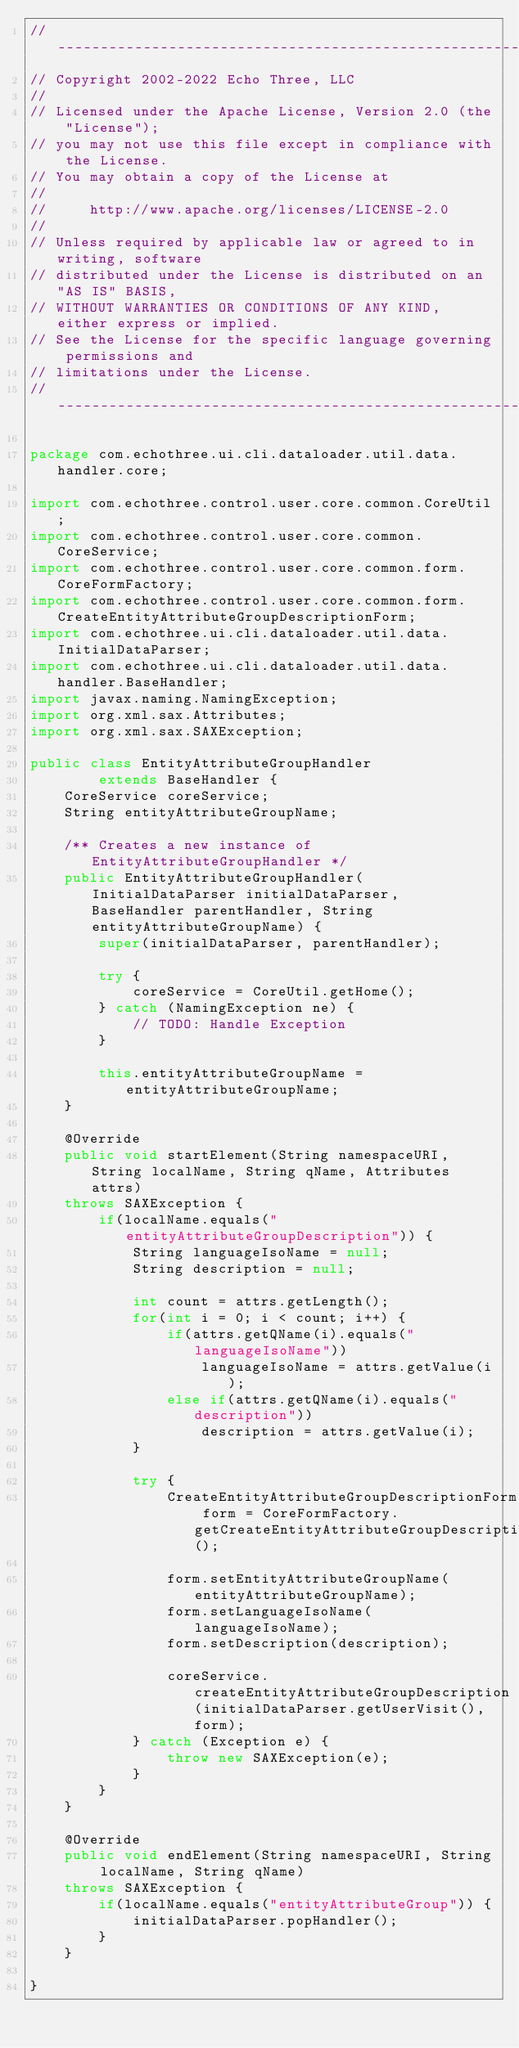Convert code to text. <code><loc_0><loc_0><loc_500><loc_500><_Java_>// --------------------------------------------------------------------------------
// Copyright 2002-2022 Echo Three, LLC
//
// Licensed under the Apache License, Version 2.0 (the "License");
// you may not use this file except in compliance with the License.
// You may obtain a copy of the License at
//
//     http://www.apache.org/licenses/LICENSE-2.0
//
// Unless required by applicable law or agreed to in writing, software
// distributed under the License is distributed on an "AS IS" BASIS,
// WITHOUT WARRANTIES OR CONDITIONS OF ANY KIND, either express or implied.
// See the License for the specific language governing permissions and
// limitations under the License.
// --------------------------------------------------------------------------------

package com.echothree.ui.cli.dataloader.util.data.handler.core;

import com.echothree.control.user.core.common.CoreUtil;
import com.echothree.control.user.core.common.CoreService;
import com.echothree.control.user.core.common.form.CoreFormFactory;
import com.echothree.control.user.core.common.form.CreateEntityAttributeGroupDescriptionForm;
import com.echothree.ui.cli.dataloader.util.data.InitialDataParser;
import com.echothree.ui.cli.dataloader.util.data.handler.BaseHandler;
import javax.naming.NamingException;
import org.xml.sax.Attributes;
import org.xml.sax.SAXException;

public class EntityAttributeGroupHandler
        extends BaseHandler {
    CoreService coreService;
    String entityAttributeGroupName;
    
    /** Creates a new instance of EntityAttributeGroupHandler */
    public EntityAttributeGroupHandler(InitialDataParser initialDataParser, BaseHandler parentHandler, String entityAttributeGroupName) {
        super(initialDataParser, parentHandler);
        
        try {
            coreService = CoreUtil.getHome();
        } catch (NamingException ne) {
            // TODO: Handle Exception
        }
        
        this.entityAttributeGroupName = entityAttributeGroupName;
    }
    
    @Override
    public void startElement(String namespaceURI, String localName, String qName, Attributes attrs)
    throws SAXException {
        if(localName.equals("entityAttributeGroupDescription")) {
            String languageIsoName = null;
            String description = null;
            
            int count = attrs.getLength();
            for(int i = 0; i < count; i++) {
                if(attrs.getQName(i).equals("languageIsoName"))
                    languageIsoName = attrs.getValue(i);
                else if(attrs.getQName(i).equals("description"))
                    description = attrs.getValue(i);
            }
            
            try {
                CreateEntityAttributeGroupDescriptionForm form = CoreFormFactory.getCreateEntityAttributeGroupDescriptionForm();
                
                form.setEntityAttributeGroupName(entityAttributeGroupName);
                form.setLanguageIsoName(languageIsoName);
                form.setDescription(description);
                
                coreService.createEntityAttributeGroupDescription(initialDataParser.getUserVisit(), form);
            } catch (Exception e) {
                throw new SAXException(e);
            }
        }
    }
    
    @Override
    public void endElement(String namespaceURI, String localName, String qName)
    throws SAXException {
        if(localName.equals("entityAttributeGroup")) {
            initialDataParser.popHandler();
        }
    }
    
}
</code> 